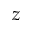<formula> <loc_0><loc_0><loc_500><loc_500>z</formula> 